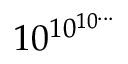Convert formula to latex. <formula><loc_0><loc_0><loc_500><loc_500>1 0 ^ { \, 1 0 ^ { 1 0 ^ { \dots } } }</formula> 